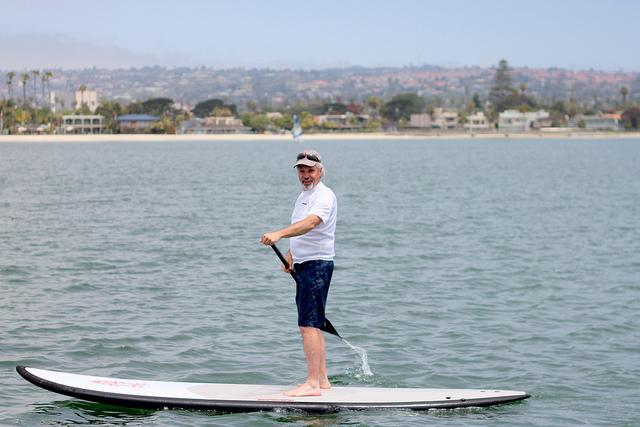Is this guy fishing?
Be succinct. No. What is the man doing?
Quick response, please. Paddle boarding. Does the man know how to swim?
Quick response, please. Yes. 